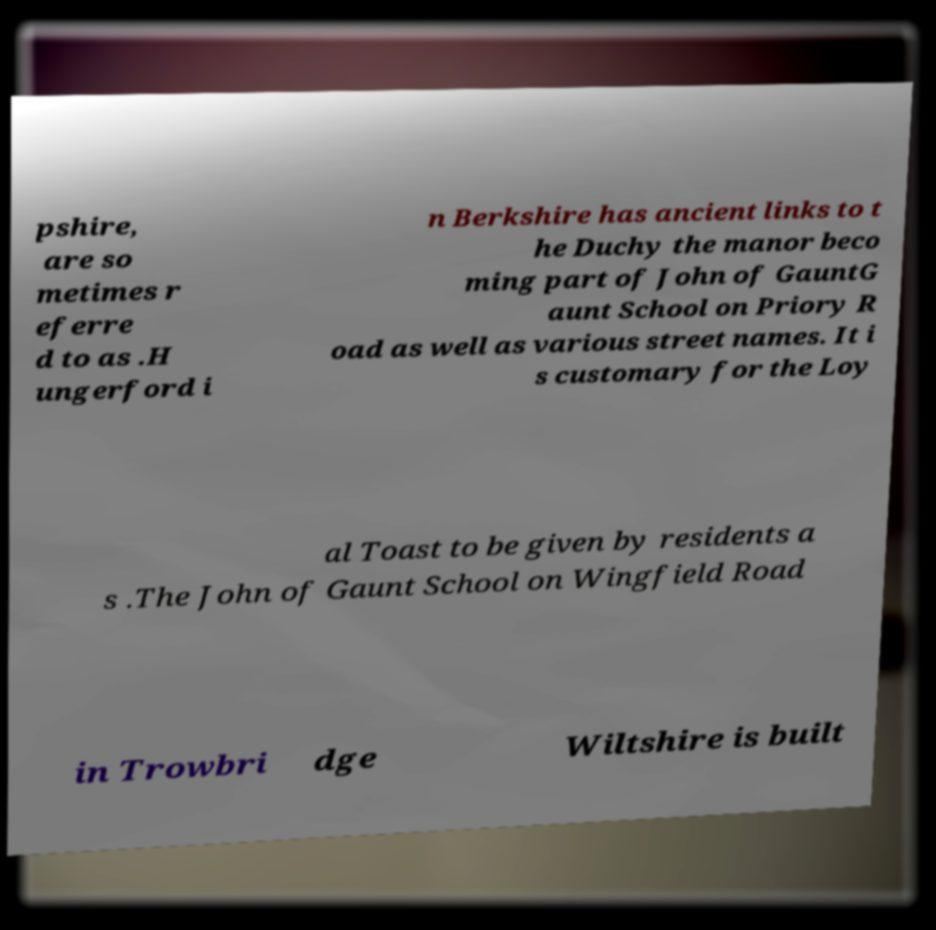Can you read and provide the text displayed in the image?This photo seems to have some interesting text. Can you extract and type it out for me? pshire, are so metimes r eferre d to as .H ungerford i n Berkshire has ancient links to t he Duchy the manor beco ming part of John of GauntG aunt School on Priory R oad as well as various street names. It i s customary for the Loy al Toast to be given by residents a s .The John of Gaunt School on Wingfield Road in Trowbri dge Wiltshire is built 